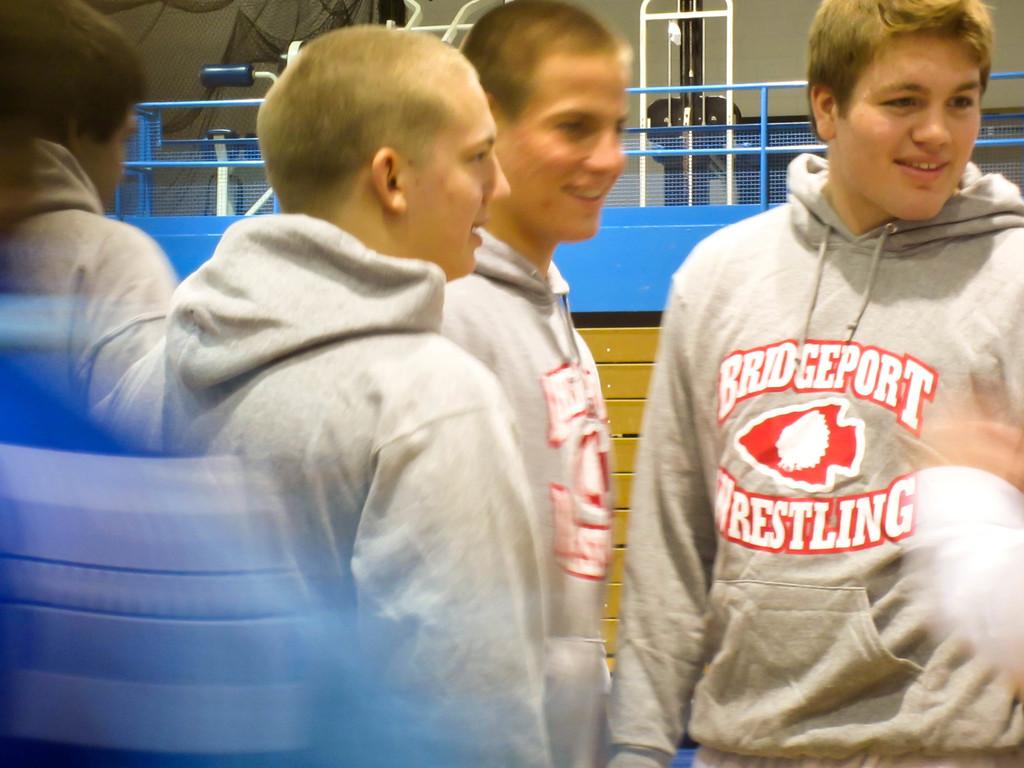What is the name of the sport the boys compete in?
Offer a very short reply. Wrestling. Which school do the boys wrestle for?
Give a very brief answer. Bridgeport. 